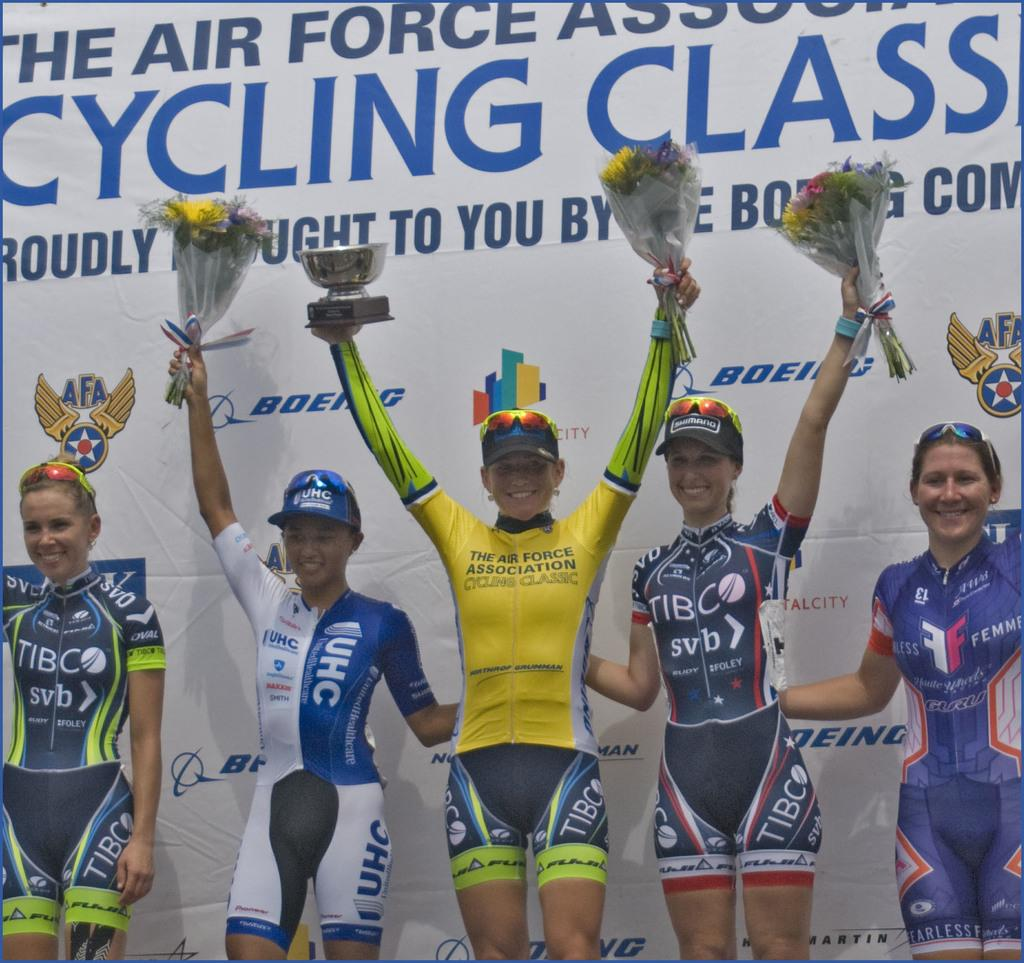<image>
Render a clear and concise summary of the photo. The female cyclists celebrate under a banner saying Cycling Class. 